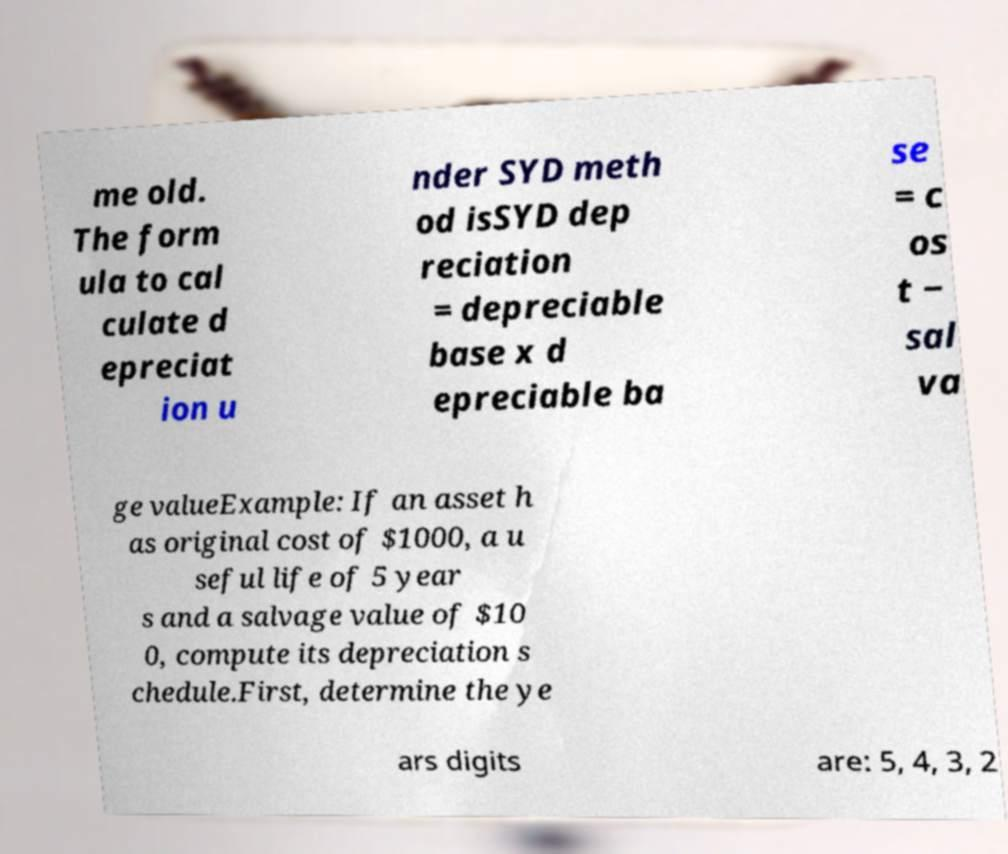Can you accurately transcribe the text from the provided image for me? me old. The form ula to cal culate d epreciat ion u nder SYD meth od isSYD dep reciation = depreciable base x d epreciable ba se = c os t − sal va ge valueExample: If an asset h as original cost of $1000, a u seful life of 5 year s and a salvage value of $10 0, compute its depreciation s chedule.First, determine the ye ars digits are: 5, 4, 3, 2 